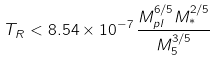<formula> <loc_0><loc_0><loc_500><loc_500>T _ { R } < 8 . 5 4 \times 1 0 ^ { - 7 } \, \frac { M _ { p l } ^ { 6 / 5 } M _ { * } ^ { 2 / 5 } } { M _ { 5 } ^ { 3 / 5 } }</formula> 